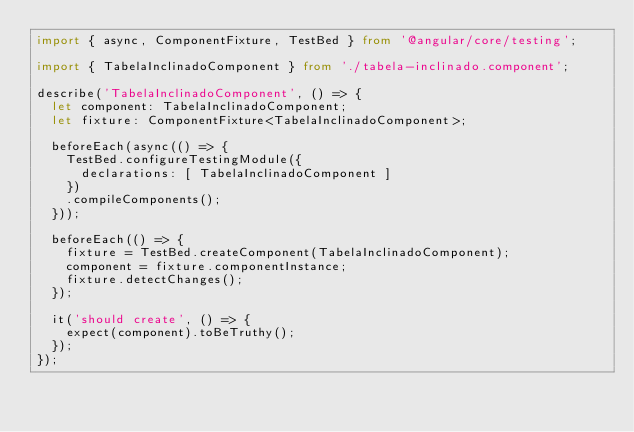Convert code to text. <code><loc_0><loc_0><loc_500><loc_500><_TypeScript_>import { async, ComponentFixture, TestBed } from '@angular/core/testing';

import { TabelaInclinadoComponent } from './tabela-inclinado.component';

describe('TabelaInclinadoComponent', () => {
  let component: TabelaInclinadoComponent;
  let fixture: ComponentFixture<TabelaInclinadoComponent>;

  beforeEach(async(() => {
    TestBed.configureTestingModule({
      declarations: [ TabelaInclinadoComponent ]
    })
    .compileComponents();
  }));

  beforeEach(() => {
    fixture = TestBed.createComponent(TabelaInclinadoComponent);
    component = fixture.componentInstance;
    fixture.detectChanges();
  });

  it('should create', () => {
    expect(component).toBeTruthy();
  });
});
</code> 